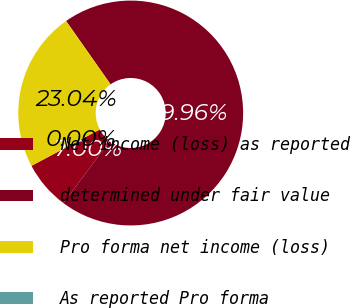Convert chart to OTSL. <chart><loc_0><loc_0><loc_500><loc_500><pie_chart><fcel>Net income (loss) as reported<fcel>determined under fair value<fcel>Pro forma net income (loss)<fcel>As reported Pro forma<nl><fcel>7.0%<fcel>69.96%<fcel>23.04%<fcel>0.0%<nl></chart> 